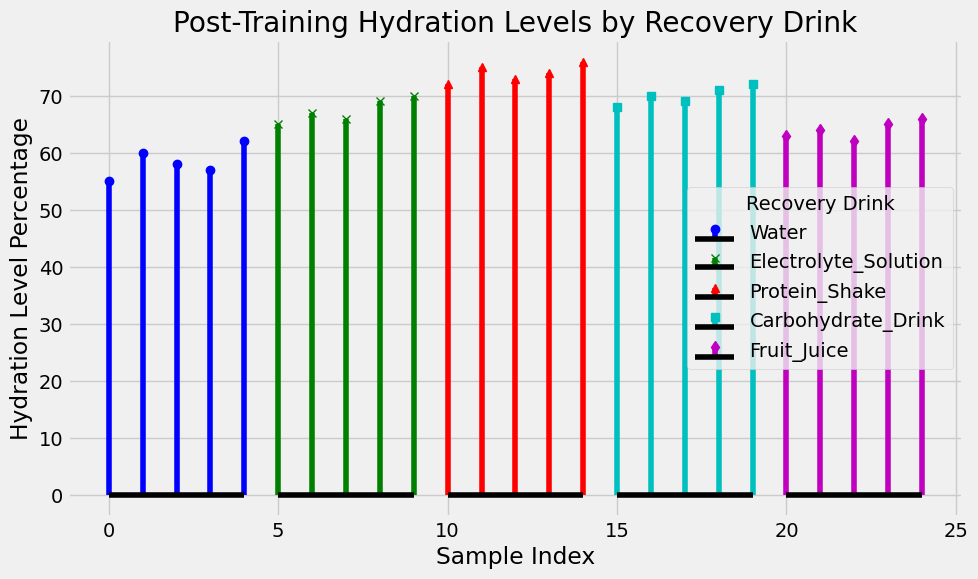Which recovery drink shows the highest hydration level percentage? To find the highest hydration level percentage, look at the tallest stem in the plot for each recovery drink. The Protein Shake's highest stem is at 76%, which is higher than the highest stems of the other drinks.
Answer: Protein Shake Which recovery drink has the lowest hydration level percentage? To identify the lowest hydration level percentage, look at the shortest stem in the plot for each recovery drink. The Water drink has the lowest stem at 55%, which is lower than the lowest stems of the other drinks.
Answer: Water What is the range of hydration levels for the Electrolyte Solution? The range is calculated by subtracting the lowest hydration level from the highest. The lowest level for Electrolyte Solution is 65% and the highest is 70%. The range is 70% - 65% = 5%.
Answer: 5% How do the hydration levels of Protein Shake compare to those of Water? To compare, look at the hydration levels of both drinks. Protein Shake ranges from 72% to 76%, while Water ranges from 55% to 62%. Protein Shake has higher hydration levels across all samples compared to Water.
Answer: Protein Shake hydration levels are higher What is the average hydration level for Fruit Juice? To calculate the average, sum the hydration levels and divide by the number of samples. The levels are 63%, 64%, 62%, 65%, and 66%. The sum is 63 + 64 + 62 + 65 + 66 = 320. The average is 320 / 5 = 64%.
Answer: 64% Which recovery drink has the most consistent hydration levels? Consistency can be inferred from the spread of the hydration levels in the plot. The narrowest range indicates consistency. Protein Shake shows levels from 72% to 76%, a range of 4%. Electrolyte Solution has a range of 5%, Carbohydrate Drink 4%, Fruit Juice 4%, and Water 7%. Thus, Protein Shake, Carbohydrate Drink, and Fruit Juice are equally consistent with the smallest range of 4%.
Answer: Protein Shake, Carbohydrate Drink, and Fruit Juice Which recovery drink has the largest variability in hydration levels? Variability can be inferred from the spread of the hydration levels. The widest range indicates the largest variability. Water has hydration levels from 55% to 62%, a range of 7%. This is wider than any other drink.
Answer: Water How much higher is the highest hydration level of Carbohydrate Drink compared to the highest hydration level of Water? Compare the highest stems of both drinks. The highest level for Carbohydrate Drink is 72% and for Water is 62%. The difference is 72% - 62% = 10%.
Answer: 10% 